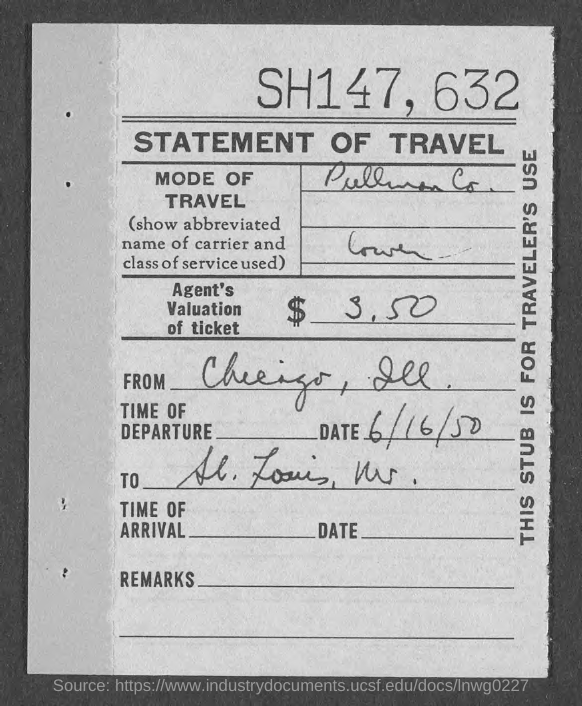Identify some key points in this picture. What is the date of departure? It is June 16, 1950. The ticket's valuation is $3.50. 